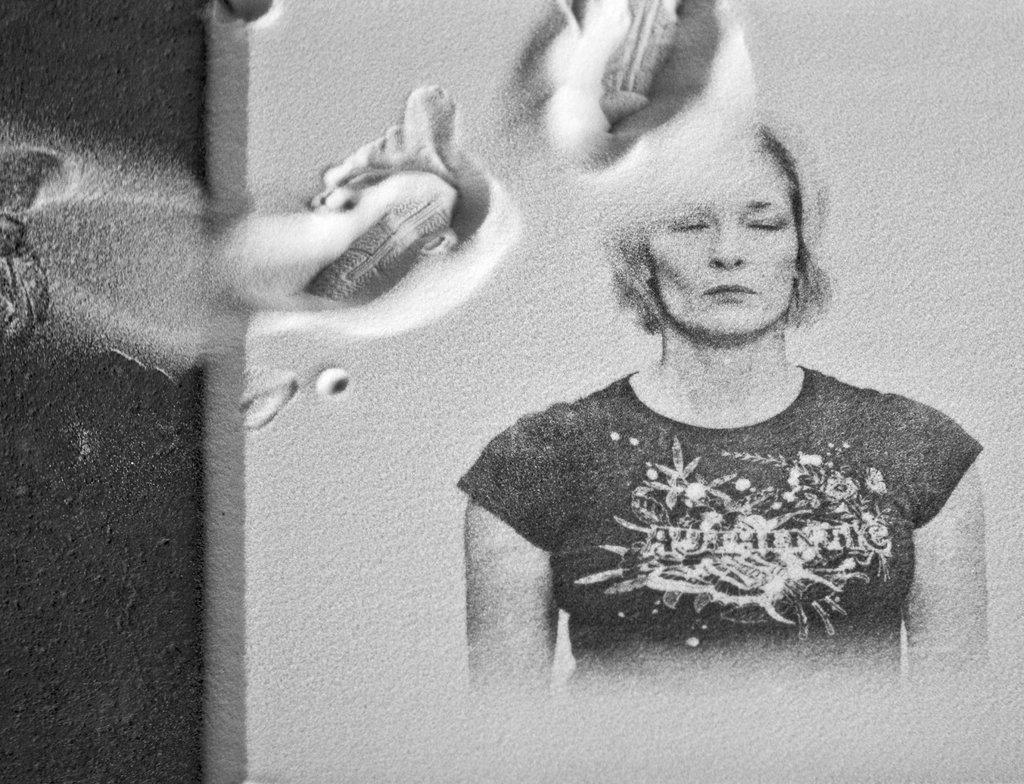What type of art is shown in the image? The image is a sand art. What is the main subject of the sand art? There is a woman depicted in the sand art. What is the woman wearing in the sand art? The woman is wearing a t-shirt. What country is the woman from in the sand art? The sand art does not provide information about the woman's country of origin. How many pets does the woman have in the sand art? There are no pets depicted in the sand art. 